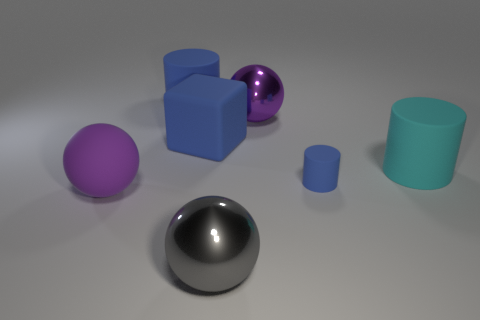Which object stands out the most in this image and why? The shiny purple sphere stands out the most due to its reflective surface which catches the light, creating highlights and making it more eye-catching compared to the other objects with matte finishes. 